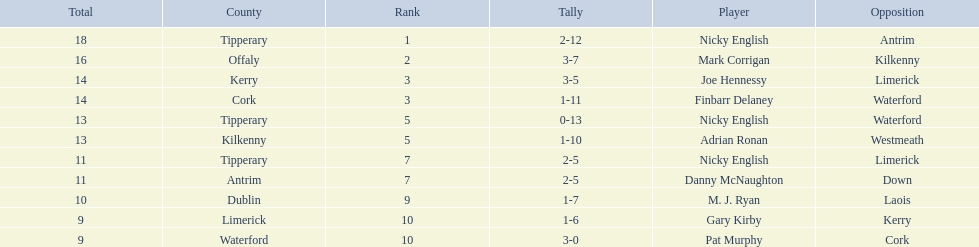If you added all the total's up, what would the number be? 138. Could you parse the entire table as a dict? {'header': ['Total', 'County', 'Rank', 'Tally', 'Player', 'Opposition'], 'rows': [['18', 'Tipperary', '1', '2-12', 'Nicky English', 'Antrim'], ['16', 'Offaly', '2', '3-7', 'Mark Corrigan', 'Kilkenny'], ['14', 'Kerry', '3', '3-5', 'Joe Hennessy', 'Limerick'], ['14', 'Cork', '3', '1-11', 'Finbarr Delaney', 'Waterford'], ['13', 'Tipperary', '5', '0-13', 'Nicky English', 'Waterford'], ['13', 'Kilkenny', '5', '1-10', 'Adrian Ronan', 'Westmeath'], ['11', 'Tipperary', '7', '2-5', 'Nicky English', 'Limerick'], ['11', 'Antrim', '7', '2-5', 'Danny McNaughton', 'Down'], ['10', 'Dublin', '9', '1-7', 'M. J. Ryan', 'Laois'], ['9', 'Limerick', '10', '1-6', 'Gary Kirby', 'Kerry'], ['9', 'Waterford', '10', '3-0', 'Pat Murphy', 'Cork']]} 